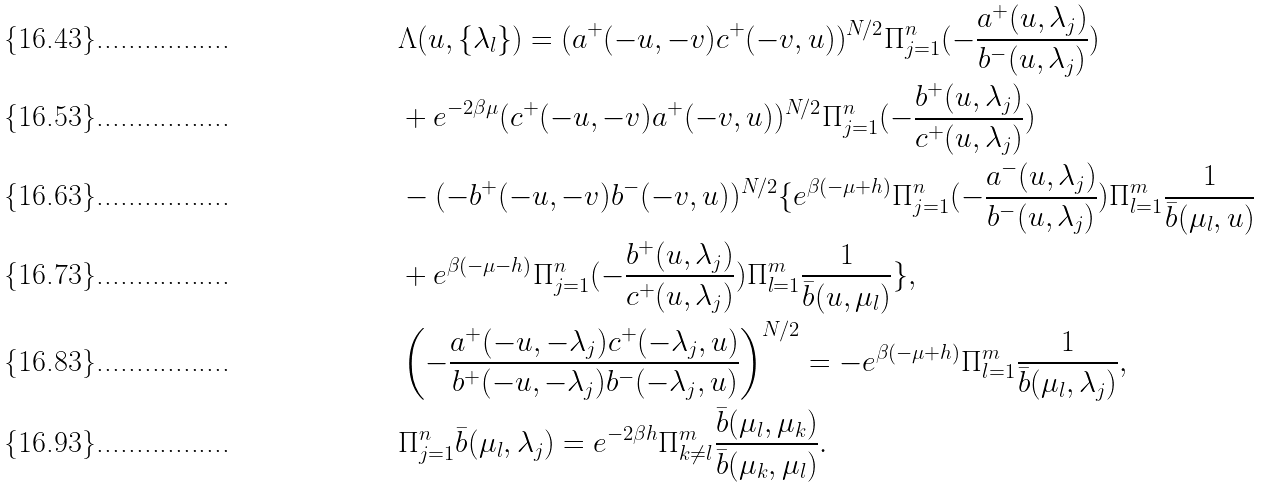<formula> <loc_0><loc_0><loc_500><loc_500>& \Lambda ( u , \{ \lambda _ { l } \} ) = ( a ^ { + } ( - u , - v ) c ^ { + } ( - v , u ) ) ^ { N / 2 } \Pi _ { j = 1 } ^ { n } ( - \frac { a ^ { + } ( u , \lambda _ { j } ) } { b ^ { - } ( u , \lambda _ { j } ) } ) \\ & + e ^ { - 2 \beta \mu } ( c ^ { + } ( - u , - v ) a ^ { + } ( - v , u ) ) ^ { N / 2 } \Pi _ { j = 1 } ^ { n } ( - \frac { b ^ { + } ( u , \lambda _ { j } ) } { c ^ { + } ( u , \lambda _ { j } ) } ) \\ & - ( - b ^ { + } ( - u , - v ) b ^ { - } ( - v , u ) ) ^ { N / 2 } \{ e ^ { \beta ( - \mu + h ) } \Pi _ { j = 1 } ^ { n } ( - \frac { a ^ { - } ( u , \lambda _ { j } ) } { b ^ { - } ( u , \lambda _ { j } ) } ) \Pi _ { l = 1 } ^ { m } \frac { 1 } { \bar { b } ( \mu _ { l } , u ) } \\ & + e ^ { \beta ( - \mu - h ) } \Pi _ { j = 1 } ^ { n } ( - \frac { b ^ { + } ( u , \lambda _ { j } ) } { c ^ { + } ( u , \lambda _ { j } ) } ) \Pi _ { l = 1 } ^ { m } \frac { 1 } { \bar { b } ( u , \mu _ { l } ) } \} , \\ & \left ( - \frac { a ^ { + } ( - u , - \lambda _ { j } ) c ^ { + } ( - \lambda _ { j } , u ) } { b ^ { + } ( - u , - \lambda _ { j } ) b ^ { - } ( - \lambda _ { j } , u ) } \right ) ^ { N / 2 } = - e ^ { \beta ( - \mu + h ) } \Pi _ { l = 1 } ^ { m } \frac { 1 } { \bar { b } ( \mu _ { l } , \lambda _ { j } ) } , \\ & \Pi _ { j = 1 } ^ { n } \bar { b } ( \mu _ { l } , \lambda _ { j } ) = e ^ { - 2 \beta h } \Pi _ { k \neq l } ^ { m } \frac { \bar { b } ( \mu _ { l } , \mu _ { k } ) } { \bar { b } ( \mu _ { k } , \mu _ { l } ) } .</formula> 